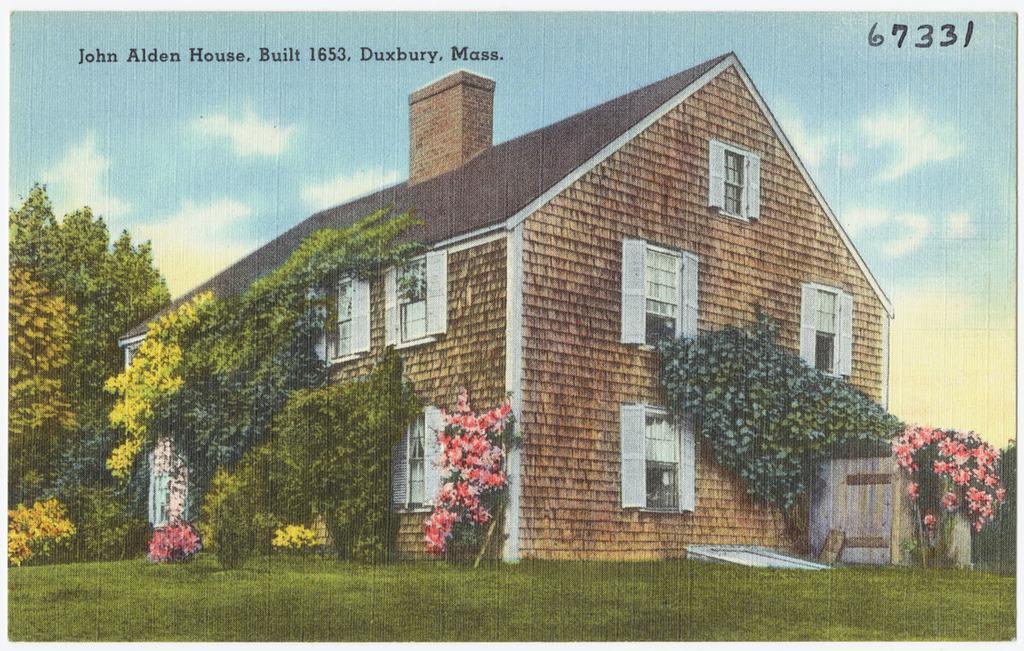Describe this image in one or two sentences. In this picture, it looks like a photo of a house. On the left and right side of the house there are trees and grass. Behind the house, there is the sky. On the photo, there are words and numbers. 